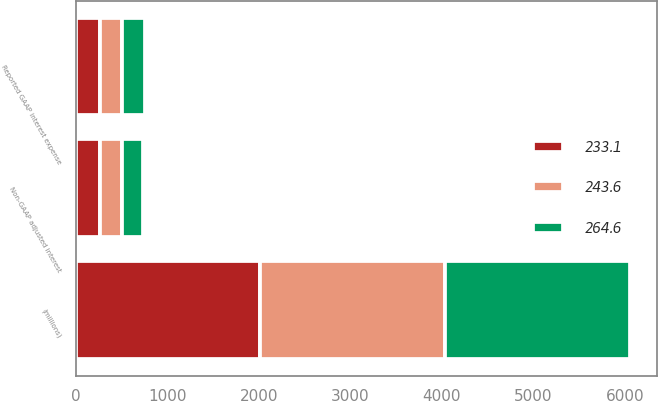Convert chart. <chart><loc_0><loc_0><loc_500><loc_500><stacked_bar_chart><ecel><fcel>(millions)<fcel>Reported GAAP interest expense<fcel>Non-GAAP adjusted interest<nl><fcel>264.6<fcel>2017<fcel>255<fcel>233.1<nl><fcel>233.1<fcel>2016<fcel>264.6<fcel>264.6<nl><fcel>243.6<fcel>2015<fcel>243.6<fcel>243.6<nl></chart> 